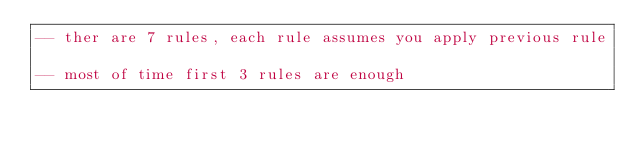Convert code to text. <code><loc_0><loc_0><loc_500><loc_500><_SQL_>-- ther are 7 rules, each rule assumes you apply previous rule

-- most of time first 3 rules are enough</code> 